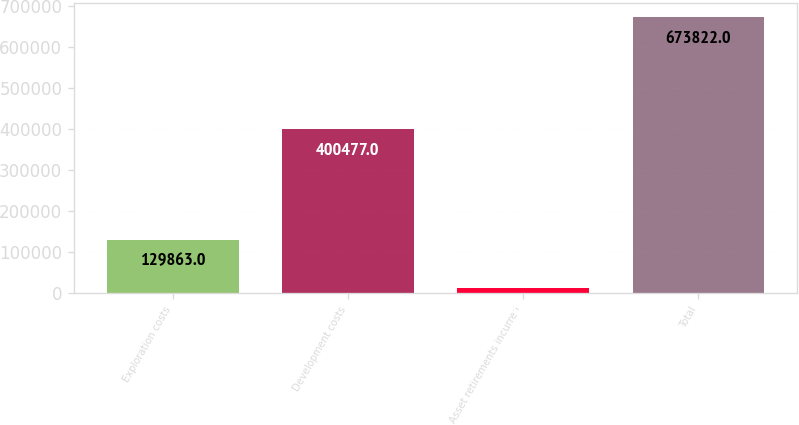Convert chart. <chart><loc_0><loc_0><loc_500><loc_500><bar_chart><fcel>Exploration costs<fcel>Development costs<fcel>Asset retirements incurred<fcel>Total<nl><fcel>129863<fcel>400477<fcel>13016<fcel>673822<nl></chart> 